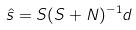Convert formula to latex. <formula><loc_0><loc_0><loc_500><loc_500>\hat { s } = S ( S + N ) ^ { - 1 } d</formula> 